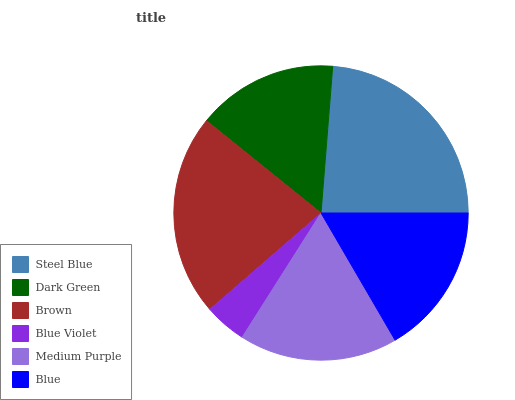Is Blue Violet the minimum?
Answer yes or no. Yes. Is Steel Blue the maximum?
Answer yes or no. Yes. Is Dark Green the minimum?
Answer yes or no. No. Is Dark Green the maximum?
Answer yes or no. No. Is Steel Blue greater than Dark Green?
Answer yes or no. Yes. Is Dark Green less than Steel Blue?
Answer yes or no. Yes. Is Dark Green greater than Steel Blue?
Answer yes or no. No. Is Steel Blue less than Dark Green?
Answer yes or no. No. Is Medium Purple the high median?
Answer yes or no. Yes. Is Blue the low median?
Answer yes or no. Yes. Is Blue Violet the high median?
Answer yes or no. No. Is Dark Green the low median?
Answer yes or no. No. 